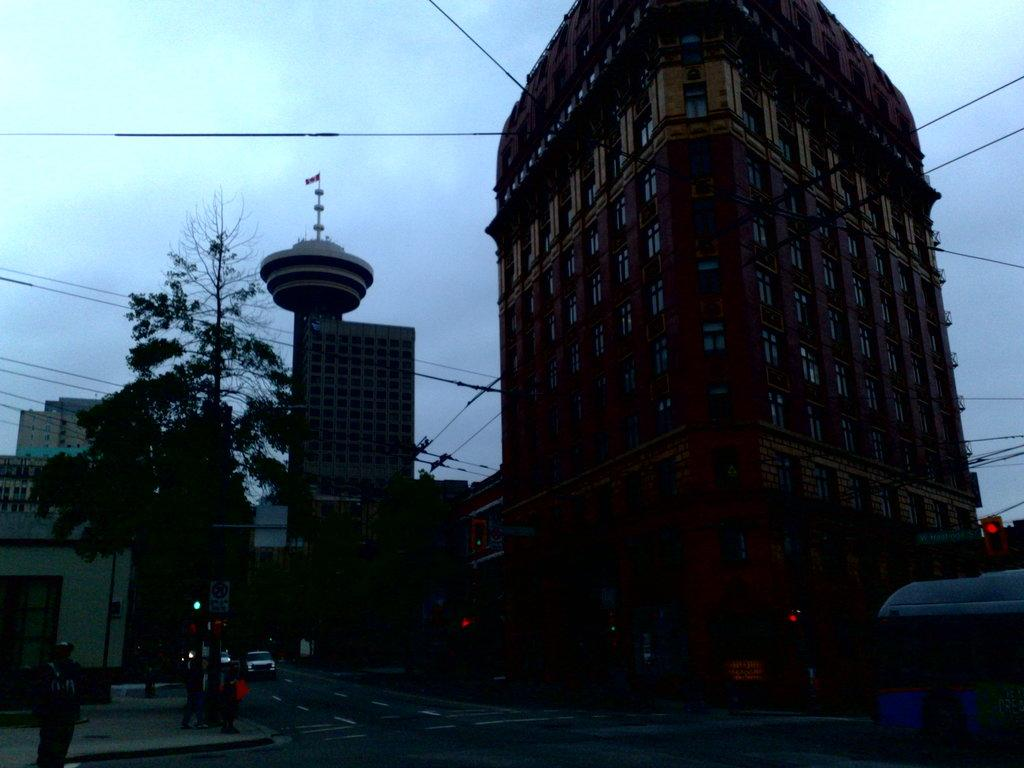What type of structures can be seen in the image? There are buildings in the image. What type of vegetation is present in the image? There are trees in the image. What else can be seen in the image besides buildings and trees? There are wires and persons visible in the image. What is the condition of the sky in the image? The sky is cloudy in the image. What type of liquid is being poured from the buildings in the image? There is no liquid being poured from the buildings in the image. What type of wax is being used to create the trees in the image? There is no wax being used to create the trees in the image; they are actual trees. What type of yam is being used to create the wires in the image? There is no yam being used to create the wires in the image; they are actual wires. 